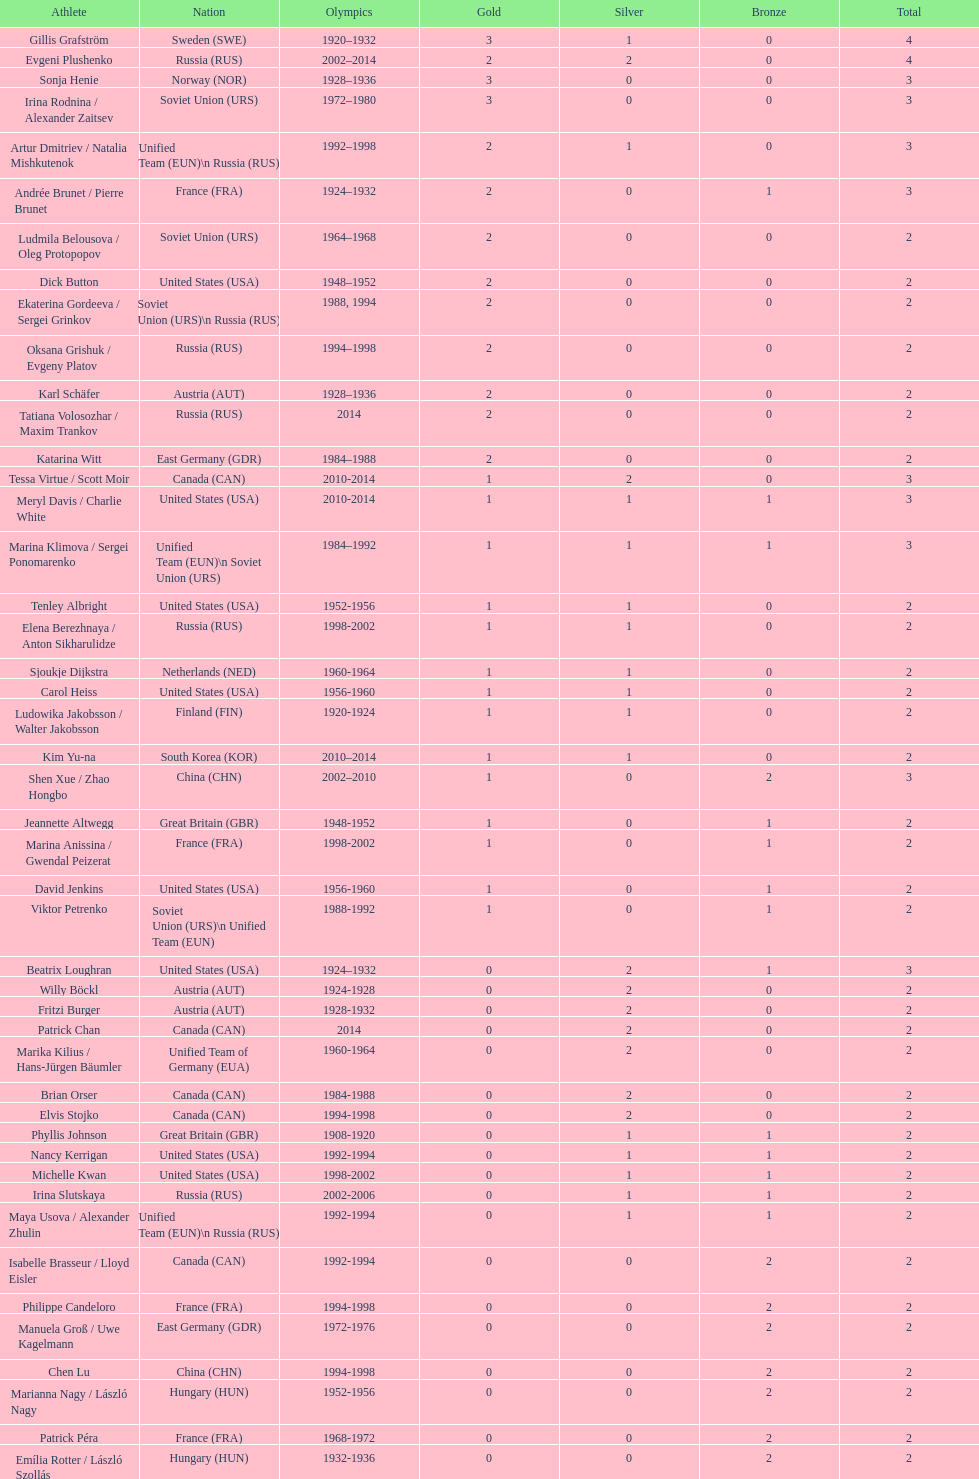How many silver medals did evgeni plushenko get? 2. 